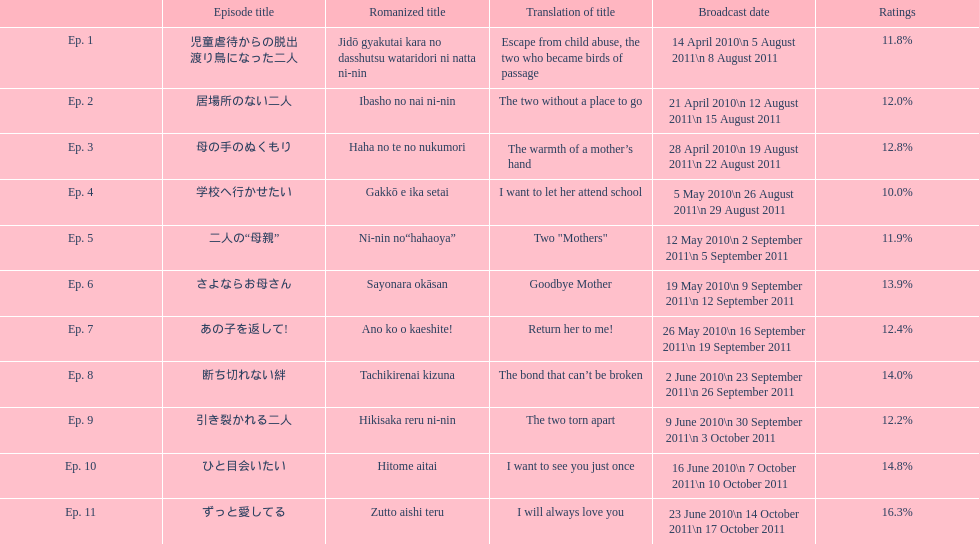Which episode was named "i want to let her go to school"? Ep. 4. 